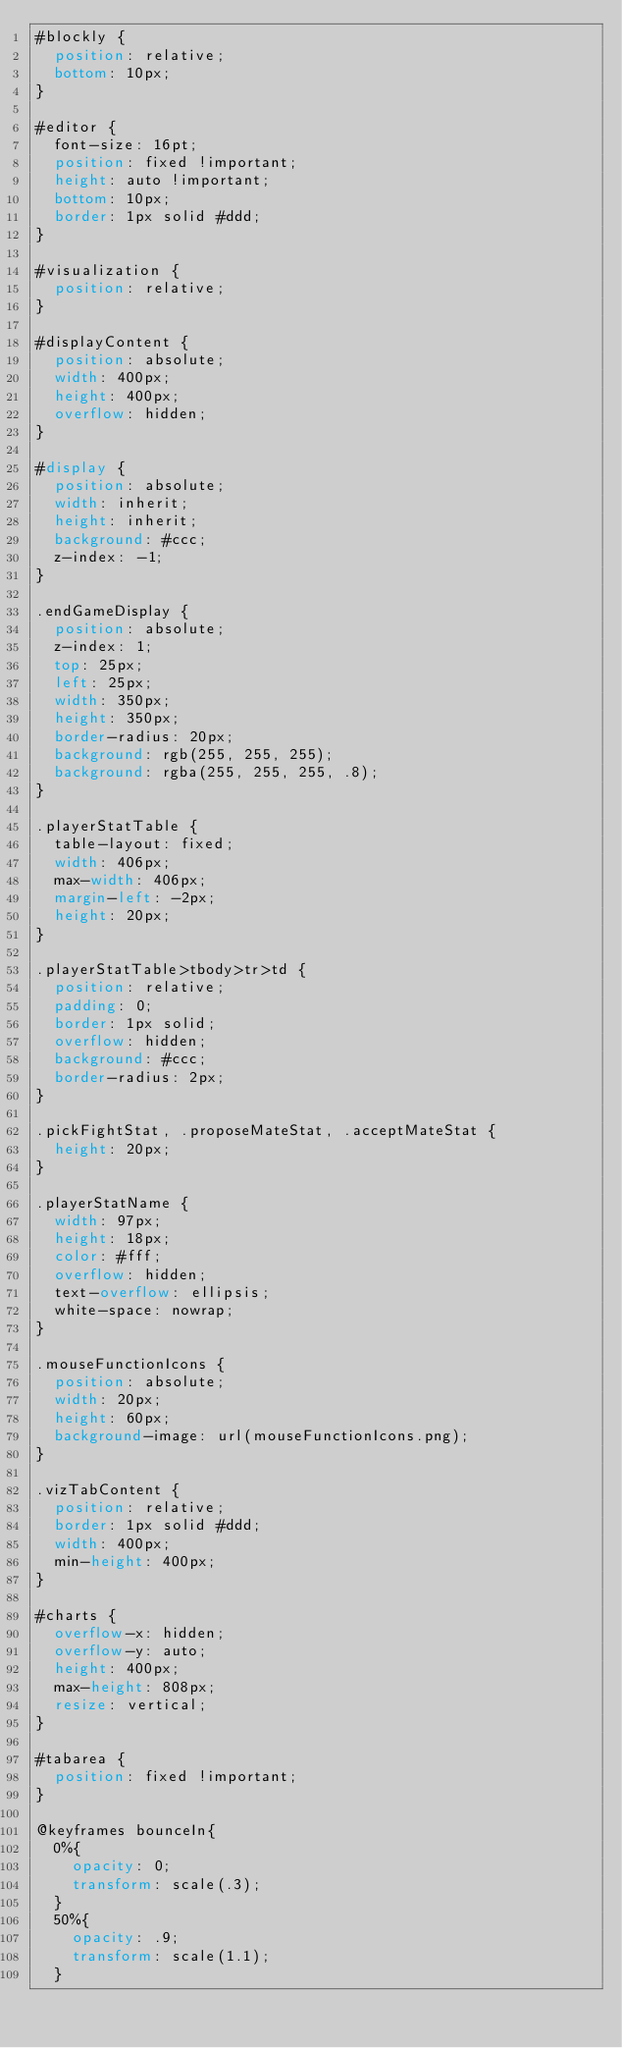Convert code to text. <code><loc_0><loc_0><loc_500><loc_500><_CSS_>#blockly {
  position: relative;
  bottom: 10px;
}

#editor {
  font-size: 16pt;
  position: fixed !important;
  height: auto !important;
  bottom: 10px;
  border: 1px solid #ddd;
}

#visualization {
  position: relative;
}

#displayContent {
  position: absolute;
  width: 400px;
  height: 400px;
  overflow: hidden;
}

#display {
  position: absolute;
  width: inherit;
  height: inherit;
  background: #ccc;
  z-index: -1;
}

.endGameDisplay {
  position: absolute;
  z-index: 1;
  top: 25px;
  left: 25px;
  width: 350px;
  height: 350px;
  border-radius: 20px;
  background: rgb(255, 255, 255);
  background: rgba(255, 255, 255, .8);
}

.playerStatTable {
  table-layout: fixed;
  width: 406px;
  max-width: 406px;
  margin-left: -2px;
  height: 20px;
}

.playerStatTable>tbody>tr>td {
  position: relative;
  padding: 0;
  border: 1px solid;
  overflow: hidden;
  background: #ccc;
  border-radius: 2px;
}

.pickFightStat, .proposeMateStat, .acceptMateStat {
  height: 20px;
}

.playerStatName {
  width: 97px;
  height: 18px;
  color: #fff;
  overflow: hidden;
  text-overflow: ellipsis;
  white-space: nowrap;
}

.mouseFunctionIcons {
  position: absolute;
  width: 20px;
  height: 60px;
  background-image: url(mouseFunctionIcons.png);
}

.vizTabContent {
  position: relative;
  border: 1px solid #ddd;
  width: 400px;
  min-height: 400px;
}

#charts {
  overflow-x: hidden;
  overflow-y: auto;
  height: 400px;
  max-height: 808px;
  resize: vertical;
}

#tabarea {
  position: fixed !important;
}

@keyframes bounceIn{
  0%{
    opacity: 0;
    transform: scale(.3);
  }
  50%{
    opacity: .9;
    transform: scale(1.1);
  }</code> 